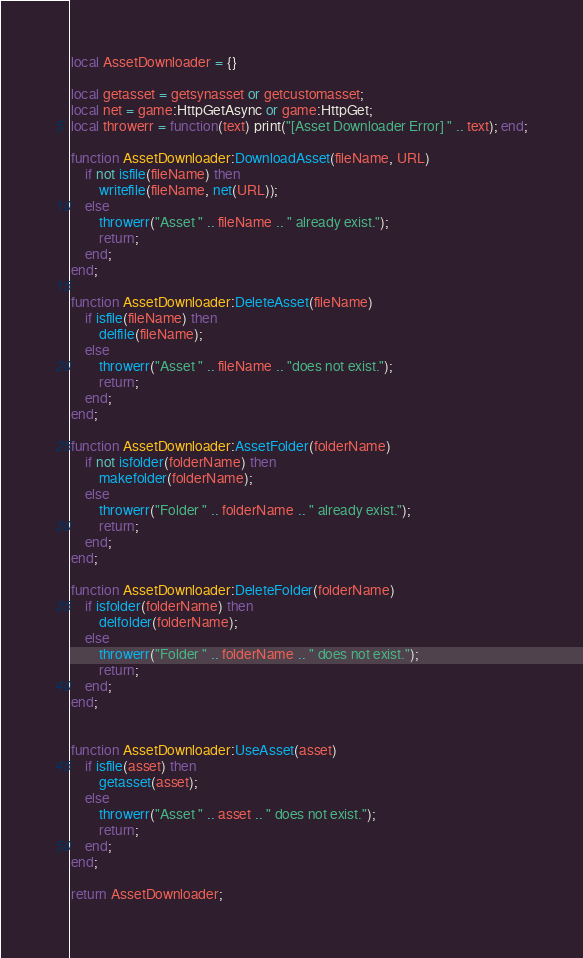<code> <loc_0><loc_0><loc_500><loc_500><_Lua_>local AssetDownloader = {}

local getasset = getsynasset or getcustomasset;
local net = game:HttpGetAsync or game:HttpGet;
local throwerr = function(text) print("[Asset Downloader Error] " .. text); end;

function AssetDownloader:DownloadAsset(fileName, URL)
    if not isfile(fileName) then
        writefile(fileName, net(URL));
    else
        throwerr("Asset " .. fileName .. " already exist.");
        return;
    end;
end;

function AssetDownloader:DeleteAsset(fileName)
    if isfile(fileName) then
        delfile(fileName);
    else
        throwerr("Asset " .. fileName .. "does not exist.");
        return;
    end;
end;

function AssetDownloader:AssetFolder(folderName)
    if not isfolder(folderName) then
        makefolder(folderName);
    else
        throwerr("Folder " .. folderName .. " already exist.");
        return;
    end;
end;

function AssetDownloader:DeleteFolder(folderName)
    if isfolder(folderName) then
        delfolder(folderName);
    else
        throwerr("Folder " .. folderName .. " does not exist.");
        return;
    end;
end;
        

function AssetDownloader:UseAsset(asset)
    if isfile(asset) then
        getasset(asset);
    else
        throwerr("Asset " .. asset .. " does not exist.");
        return;
    end;
end;

return AssetDownloader;
</code> 